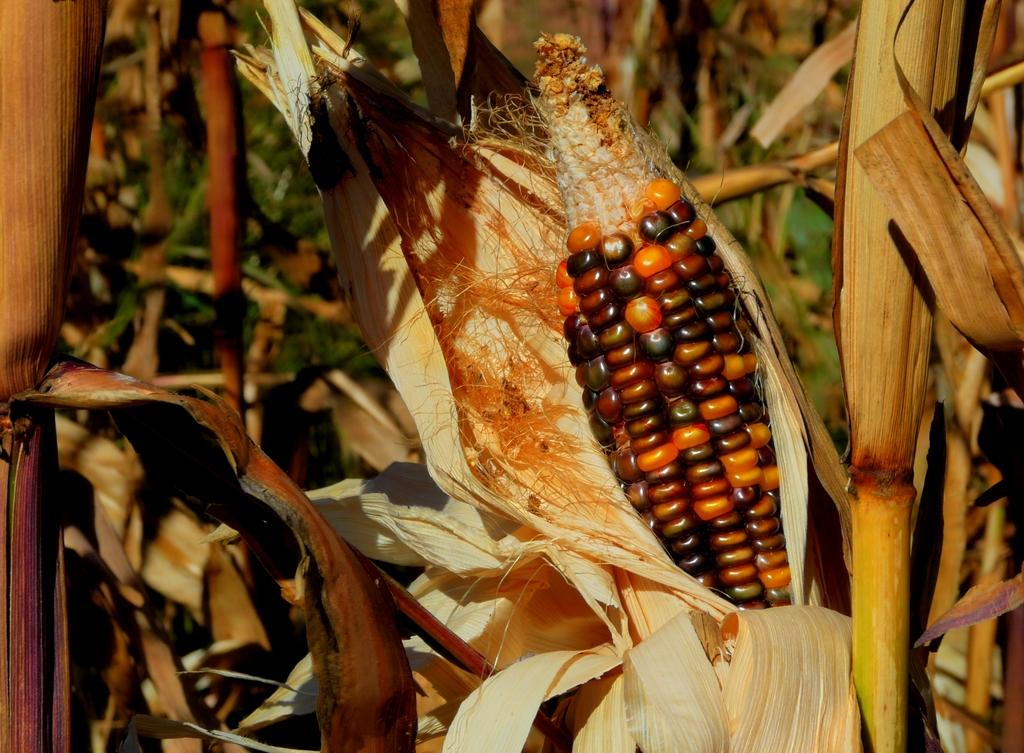What is the main subject of the image? There is a maize in the image. What can be seen behind the maize? There are leaves and stalks behind the maize. How many birds are in the flock that is sitting on the desk in the image? There is no flock of birds or desk present in the image; it features a maize with leaves and stalks behind it. 